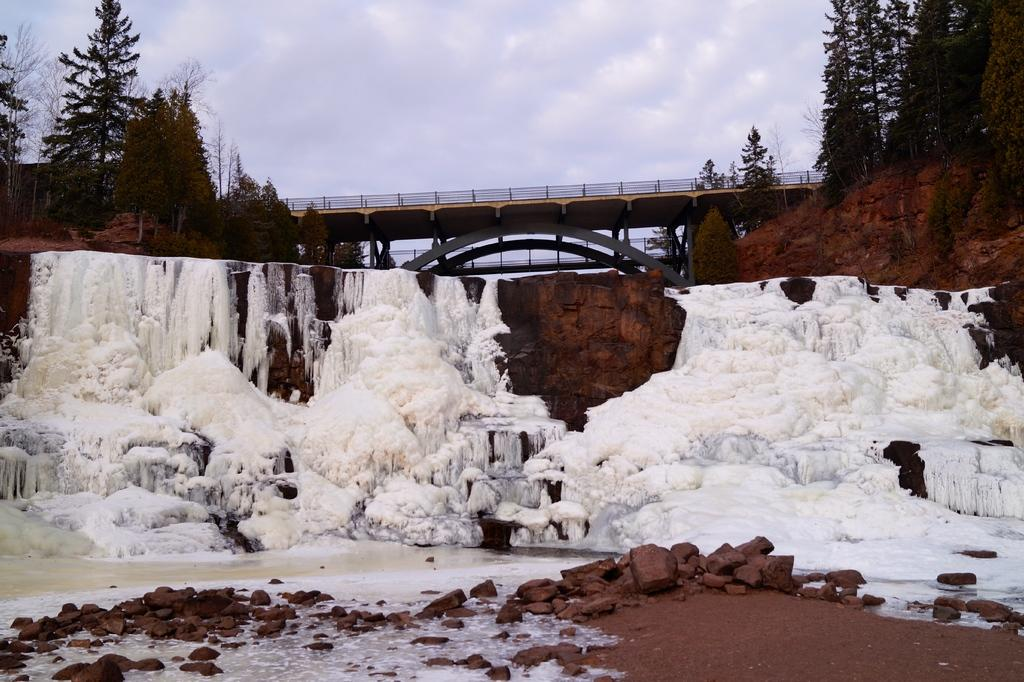What is the primary feature of the landscape in the image? There is snow in the image. What structure can be seen in the background of the image? There is a bridge in the background of the image. What type of vegetation is present on either side of the bridge? There are trees on either side of the bridge. What part of the natural environment is visible in the image? The sky is visible in the image. How many beds are visible in the image? There are no beds present in the image. What type of pet can be seen interacting with the snow in the image? There is no pet present in the image; it only features snow, a bridge, trees, and the sky. 